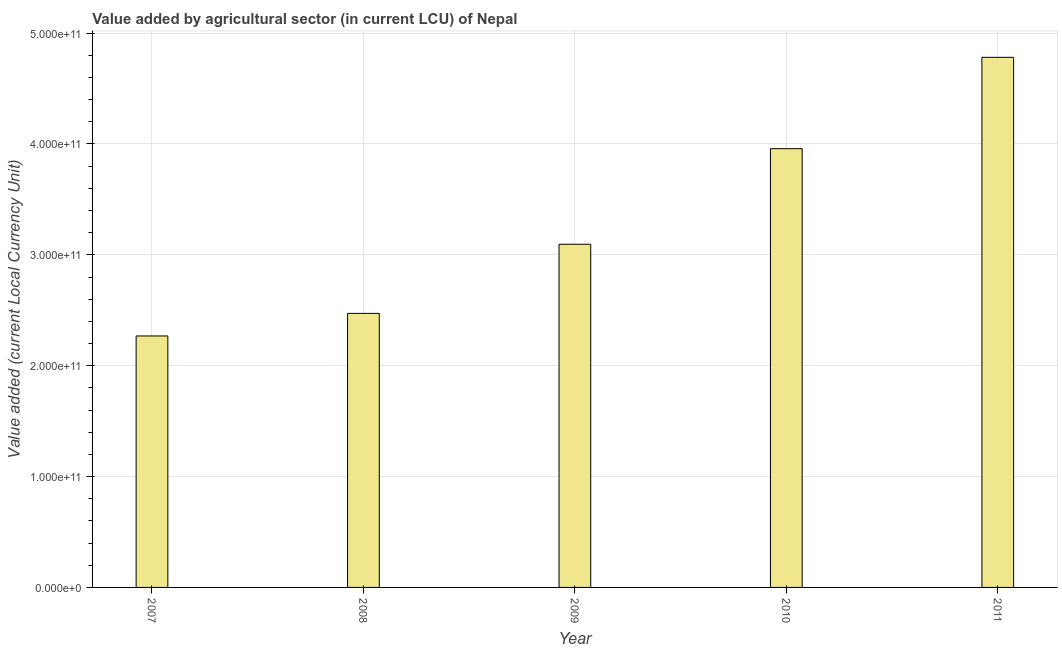Does the graph contain any zero values?
Provide a short and direct response. No. What is the title of the graph?
Provide a succinct answer. Value added by agricultural sector (in current LCU) of Nepal. What is the label or title of the Y-axis?
Make the answer very short. Value added (current Local Currency Unit). What is the value added by agriculture sector in 2008?
Give a very brief answer. 2.47e+11. Across all years, what is the maximum value added by agriculture sector?
Give a very brief answer. 4.78e+11. Across all years, what is the minimum value added by agriculture sector?
Provide a succinct answer. 2.27e+11. What is the sum of the value added by agriculture sector?
Offer a terse response. 1.66e+12. What is the difference between the value added by agriculture sector in 2009 and 2011?
Your answer should be very brief. -1.69e+11. What is the average value added by agriculture sector per year?
Your answer should be very brief. 3.31e+11. What is the median value added by agriculture sector?
Offer a very short reply. 3.10e+11. In how many years, is the value added by agriculture sector greater than 480000000000 LCU?
Offer a terse response. 0. What is the ratio of the value added by agriculture sector in 2008 to that in 2009?
Offer a very short reply. 0.8. Is the value added by agriculture sector in 2010 less than that in 2011?
Your answer should be very brief. Yes. What is the difference between the highest and the second highest value added by agriculture sector?
Offer a very short reply. 8.24e+1. Is the sum of the value added by agriculture sector in 2007 and 2011 greater than the maximum value added by agriculture sector across all years?
Your answer should be compact. Yes. What is the difference between the highest and the lowest value added by agriculture sector?
Your answer should be compact. 2.51e+11. Are all the bars in the graph horizontal?
Your answer should be very brief. No. How many years are there in the graph?
Provide a succinct answer. 5. What is the difference between two consecutive major ticks on the Y-axis?
Make the answer very short. 1.00e+11. Are the values on the major ticks of Y-axis written in scientific E-notation?
Offer a very short reply. Yes. What is the Value added (current Local Currency Unit) in 2007?
Your answer should be very brief. 2.27e+11. What is the Value added (current Local Currency Unit) in 2008?
Give a very brief answer. 2.47e+11. What is the Value added (current Local Currency Unit) in 2009?
Your answer should be compact. 3.10e+11. What is the Value added (current Local Currency Unit) in 2010?
Keep it short and to the point. 3.96e+11. What is the Value added (current Local Currency Unit) in 2011?
Provide a short and direct response. 4.78e+11. What is the difference between the Value added (current Local Currency Unit) in 2007 and 2008?
Offer a terse response. -2.04e+1. What is the difference between the Value added (current Local Currency Unit) in 2007 and 2009?
Make the answer very short. -8.27e+1. What is the difference between the Value added (current Local Currency Unit) in 2007 and 2010?
Make the answer very short. -1.69e+11. What is the difference between the Value added (current Local Currency Unit) in 2007 and 2011?
Offer a terse response. -2.51e+11. What is the difference between the Value added (current Local Currency Unit) in 2008 and 2009?
Offer a terse response. -6.24e+1. What is the difference between the Value added (current Local Currency Unit) in 2008 and 2010?
Provide a short and direct response. -1.49e+11. What is the difference between the Value added (current Local Currency Unit) in 2008 and 2011?
Your answer should be very brief. -2.31e+11. What is the difference between the Value added (current Local Currency Unit) in 2009 and 2010?
Your answer should be compact. -8.62e+1. What is the difference between the Value added (current Local Currency Unit) in 2009 and 2011?
Your answer should be compact. -1.69e+11. What is the difference between the Value added (current Local Currency Unit) in 2010 and 2011?
Keep it short and to the point. -8.24e+1. What is the ratio of the Value added (current Local Currency Unit) in 2007 to that in 2008?
Provide a succinct answer. 0.92. What is the ratio of the Value added (current Local Currency Unit) in 2007 to that in 2009?
Your response must be concise. 0.73. What is the ratio of the Value added (current Local Currency Unit) in 2007 to that in 2010?
Offer a terse response. 0.57. What is the ratio of the Value added (current Local Currency Unit) in 2007 to that in 2011?
Give a very brief answer. 0.47. What is the ratio of the Value added (current Local Currency Unit) in 2008 to that in 2009?
Provide a short and direct response. 0.8. What is the ratio of the Value added (current Local Currency Unit) in 2008 to that in 2011?
Provide a short and direct response. 0.52. What is the ratio of the Value added (current Local Currency Unit) in 2009 to that in 2010?
Your response must be concise. 0.78. What is the ratio of the Value added (current Local Currency Unit) in 2009 to that in 2011?
Your answer should be compact. 0.65. What is the ratio of the Value added (current Local Currency Unit) in 2010 to that in 2011?
Give a very brief answer. 0.83. 